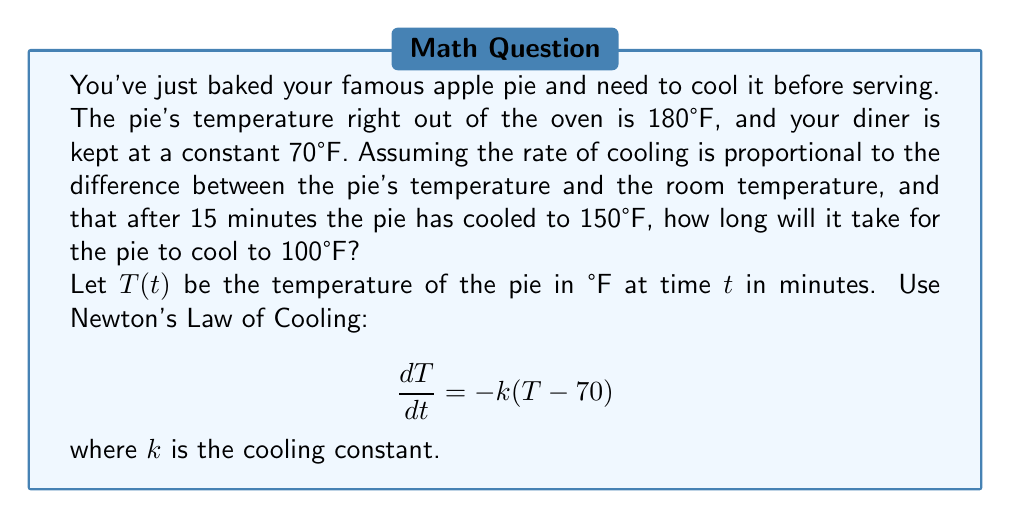Show me your answer to this math problem. Let's solve this step-by-step:

1) We start with Newton's Law of Cooling:
   $$\frac{dT}{dt} = -k(T - 70)$$

2) Separate variables and integrate:
   $$\int \frac{dT}{T - 70} = -k \int dt$$

3) Solve the integral:
   $$\ln|T - 70| = -kt + C$$

4) Take the exponential of both sides:
   $$T - 70 = Ae^{-kt}$$
   where $A = e^C$

5) Solve for $T$:
   $$T = 70 + Ae^{-kt}$$

6) Use initial condition $T(0) = 180$ to find $A$:
   $$180 = 70 + A$$
   $$A = 110$$

7) Our solution is now:
   $$T = 70 + 110e^{-kt}$$

8) Use the condition that $T(15) = 150$ to find $k$:
   $$150 = 70 + 110e^{-15k}$$
   $$80 = 110e^{-15k}$$
   $$\ln(80/110) = -15k$$
   $$k = -\frac{1}{15}\ln(80/110) \approx 0.0231$$

9) Now we can find when $T = 100$:
   $$100 = 70 + 110e^{-0.0231t}$$
   $$30 = 110e^{-0.0231t}$$
   $$\ln(30/110) = -0.0231t$$
   $$t = -\frac{1}{0.0231}\ln(30/110) \approx 58.6$$

Therefore, it will take approximately 58.6 minutes for the pie to cool to 100°F.
Answer: The pie will take approximately 58.6 minutes to cool to 100°F. 